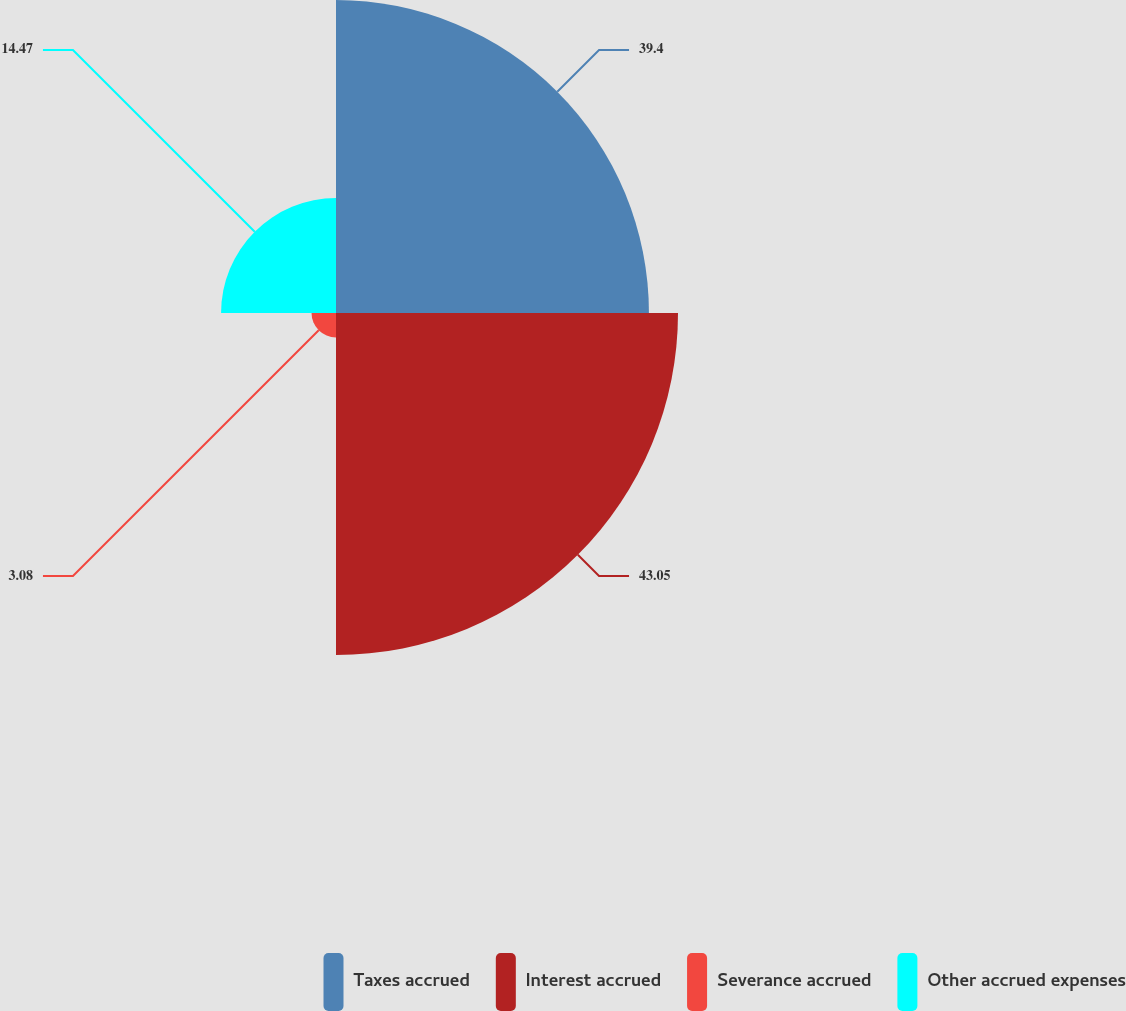Convert chart. <chart><loc_0><loc_0><loc_500><loc_500><pie_chart><fcel>Taxes accrued<fcel>Interest accrued<fcel>Severance accrued<fcel>Other accrued expenses<nl><fcel>39.4%<fcel>43.06%<fcel>3.08%<fcel>14.47%<nl></chart> 